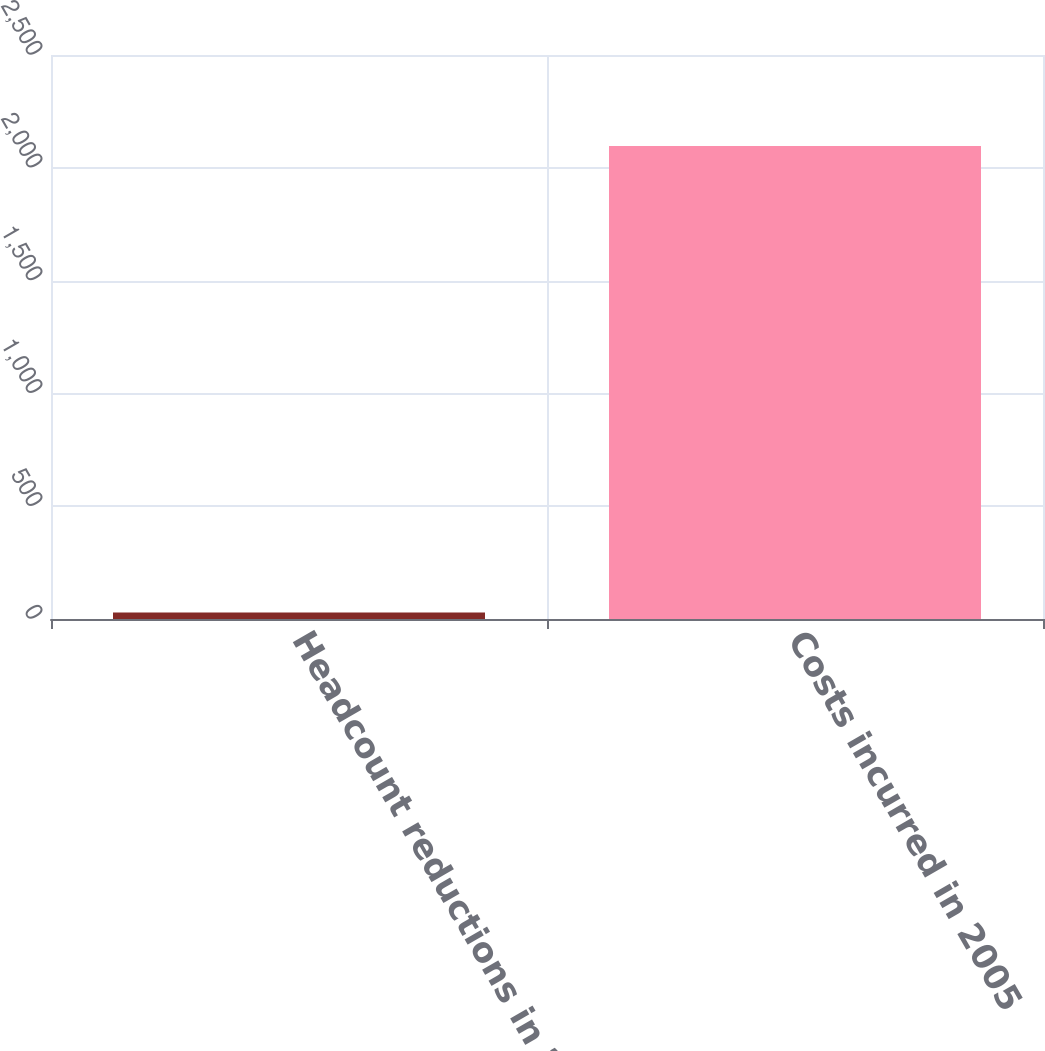Convert chart. <chart><loc_0><loc_0><loc_500><loc_500><bar_chart><fcel>Headcount reductions in 2005<fcel>Costs incurred in 2005<nl><fcel>29<fcel>2097<nl></chart> 